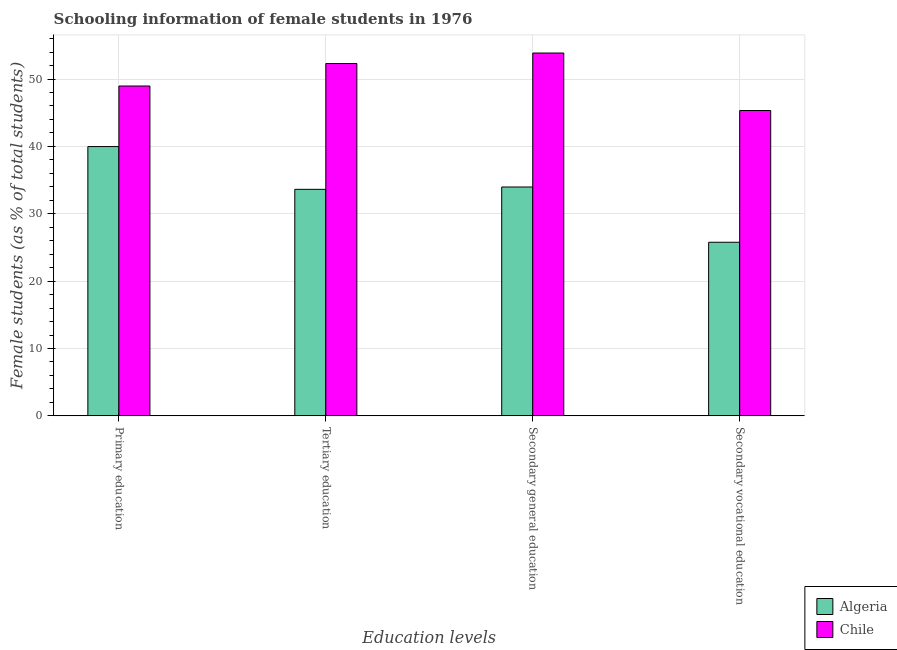Are the number of bars per tick equal to the number of legend labels?
Offer a very short reply. Yes. Are the number of bars on each tick of the X-axis equal?
Ensure brevity in your answer.  Yes. What is the percentage of female students in primary education in Algeria?
Provide a succinct answer. 39.97. Across all countries, what is the maximum percentage of female students in secondary education?
Your answer should be compact. 53.86. Across all countries, what is the minimum percentage of female students in secondary education?
Ensure brevity in your answer.  33.97. In which country was the percentage of female students in secondary education minimum?
Offer a terse response. Algeria. What is the total percentage of female students in secondary education in the graph?
Your answer should be very brief. 87.83. What is the difference between the percentage of female students in primary education in Chile and that in Algeria?
Ensure brevity in your answer.  8.99. What is the difference between the percentage of female students in primary education in Algeria and the percentage of female students in secondary vocational education in Chile?
Offer a terse response. -5.35. What is the average percentage of female students in secondary education per country?
Ensure brevity in your answer.  43.92. What is the difference between the percentage of female students in primary education and percentage of female students in secondary vocational education in Algeria?
Provide a short and direct response. 14.2. What is the ratio of the percentage of female students in secondary education in Algeria to that in Chile?
Provide a short and direct response. 0.63. Is the percentage of female students in secondary vocational education in Algeria less than that in Chile?
Give a very brief answer. Yes. Is the difference between the percentage of female students in secondary education in Algeria and Chile greater than the difference between the percentage of female students in secondary vocational education in Algeria and Chile?
Give a very brief answer. No. What is the difference between the highest and the second highest percentage of female students in secondary vocational education?
Your answer should be compact. 19.55. What is the difference between the highest and the lowest percentage of female students in secondary vocational education?
Offer a very short reply. 19.55. Is it the case that in every country, the sum of the percentage of female students in secondary vocational education and percentage of female students in secondary education is greater than the sum of percentage of female students in tertiary education and percentage of female students in primary education?
Offer a terse response. No. Is it the case that in every country, the sum of the percentage of female students in primary education and percentage of female students in tertiary education is greater than the percentage of female students in secondary education?
Provide a succinct answer. Yes. How many bars are there?
Your response must be concise. 8. Are all the bars in the graph horizontal?
Provide a succinct answer. No. What is the difference between two consecutive major ticks on the Y-axis?
Offer a very short reply. 10. Where does the legend appear in the graph?
Offer a very short reply. Bottom right. How many legend labels are there?
Ensure brevity in your answer.  2. What is the title of the graph?
Provide a short and direct response. Schooling information of female students in 1976. Does "Morocco" appear as one of the legend labels in the graph?
Provide a short and direct response. No. What is the label or title of the X-axis?
Offer a terse response. Education levels. What is the label or title of the Y-axis?
Provide a short and direct response. Female students (as % of total students). What is the Female students (as % of total students) in Algeria in Primary education?
Give a very brief answer. 39.97. What is the Female students (as % of total students) in Chile in Primary education?
Your response must be concise. 48.96. What is the Female students (as % of total students) of Algeria in Tertiary education?
Provide a short and direct response. 33.63. What is the Female students (as % of total students) in Chile in Tertiary education?
Ensure brevity in your answer.  52.3. What is the Female students (as % of total students) of Algeria in Secondary general education?
Offer a very short reply. 33.97. What is the Female students (as % of total students) in Chile in Secondary general education?
Keep it short and to the point. 53.86. What is the Female students (as % of total students) of Algeria in Secondary vocational education?
Your answer should be very brief. 25.77. What is the Female students (as % of total students) in Chile in Secondary vocational education?
Your response must be concise. 45.32. Across all Education levels, what is the maximum Female students (as % of total students) of Algeria?
Provide a short and direct response. 39.97. Across all Education levels, what is the maximum Female students (as % of total students) of Chile?
Your answer should be very brief. 53.86. Across all Education levels, what is the minimum Female students (as % of total students) of Algeria?
Your response must be concise. 25.77. Across all Education levels, what is the minimum Female students (as % of total students) in Chile?
Provide a short and direct response. 45.32. What is the total Female students (as % of total students) of Algeria in the graph?
Make the answer very short. 133.34. What is the total Female students (as % of total students) in Chile in the graph?
Your answer should be compact. 200.44. What is the difference between the Female students (as % of total students) of Algeria in Primary education and that in Tertiary education?
Your answer should be compact. 6.35. What is the difference between the Female students (as % of total students) in Chile in Primary education and that in Tertiary education?
Your answer should be very brief. -3.34. What is the difference between the Female students (as % of total students) in Algeria in Primary education and that in Secondary general education?
Offer a terse response. 6. What is the difference between the Female students (as % of total students) of Chile in Primary education and that in Secondary general education?
Make the answer very short. -4.9. What is the difference between the Female students (as % of total students) in Algeria in Primary education and that in Secondary vocational education?
Provide a short and direct response. 14.2. What is the difference between the Female students (as % of total students) of Chile in Primary education and that in Secondary vocational education?
Give a very brief answer. 3.64. What is the difference between the Female students (as % of total students) of Algeria in Tertiary education and that in Secondary general education?
Provide a short and direct response. -0.35. What is the difference between the Female students (as % of total students) in Chile in Tertiary education and that in Secondary general education?
Offer a very short reply. -1.56. What is the difference between the Female students (as % of total students) in Algeria in Tertiary education and that in Secondary vocational education?
Ensure brevity in your answer.  7.86. What is the difference between the Female students (as % of total students) of Chile in Tertiary education and that in Secondary vocational education?
Offer a very short reply. 6.97. What is the difference between the Female students (as % of total students) of Algeria in Secondary general education and that in Secondary vocational education?
Your answer should be very brief. 8.2. What is the difference between the Female students (as % of total students) of Chile in Secondary general education and that in Secondary vocational education?
Provide a succinct answer. 8.54. What is the difference between the Female students (as % of total students) of Algeria in Primary education and the Female students (as % of total students) of Chile in Tertiary education?
Provide a short and direct response. -12.32. What is the difference between the Female students (as % of total students) in Algeria in Primary education and the Female students (as % of total students) in Chile in Secondary general education?
Provide a short and direct response. -13.89. What is the difference between the Female students (as % of total students) of Algeria in Primary education and the Female students (as % of total students) of Chile in Secondary vocational education?
Your answer should be compact. -5.35. What is the difference between the Female students (as % of total students) in Algeria in Tertiary education and the Female students (as % of total students) in Chile in Secondary general education?
Your answer should be compact. -20.23. What is the difference between the Female students (as % of total students) in Algeria in Tertiary education and the Female students (as % of total students) in Chile in Secondary vocational education?
Your answer should be very brief. -11.7. What is the difference between the Female students (as % of total students) of Algeria in Secondary general education and the Female students (as % of total students) of Chile in Secondary vocational education?
Your response must be concise. -11.35. What is the average Female students (as % of total students) in Algeria per Education levels?
Provide a succinct answer. 33.34. What is the average Female students (as % of total students) in Chile per Education levels?
Keep it short and to the point. 50.11. What is the difference between the Female students (as % of total students) of Algeria and Female students (as % of total students) of Chile in Primary education?
Your response must be concise. -8.99. What is the difference between the Female students (as % of total students) of Algeria and Female students (as % of total students) of Chile in Tertiary education?
Your answer should be compact. -18.67. What is the difference between the Female students (as % of total students) of Algeria and Female students (as % of total students) of Chile in Secondary general education?
Offer a terse response. -19.89. What is the difference between the Female students (as % of total students) of Algeria and Female students (as % of total students) of Chile in Secondary vocational education?
Make the answer very short. -19.55. What is the ratio of the Female students (as % of total students) of Algeria in Primary education to that in Tertiary education?
Keep it short and to the point. 1.19. What is the ratio of the Female students (as % of total students) of Chile in Primary education to that in Tertiary education?
Give a very brief answer. 0.94. What is the ratio of the Female students (as % of total students) of Algeria in Primary education to that in Secondary general education?
Provide a succinct answer. 1.18. What is the ratio of the Female students (as % of total students) of Chile in Primary education to that in Secondary general education?
Provide a short and direct response. 0.91. What is the ratio of the Female students (as % of total students) in Algeria in Primary education to that in Secondary vocational education?
Offer a terse response. 1.55. What is the ratio of the Female students (as % of total students) of Chile in Primary education to that in Secondary vocational education?
Your response must be concise. 1.08. What is the ratio of the Female students (as % of total students) of Algeria in Tertiary education to that in Secondary general education?
Give a very brief answer. 0.99. What is the ratio of the Female students (as % of total students) of Algeria in Tertiary education to that in Secondary vocational education?
Make the answer very short. 1.3. What is the ratio of the Female students (as % of total students) of Chile in Tertiary education to that in Secondary vocational education?
Make the answer very short. 1.15. What is the ratio of the Female students (as % of total students) of Algeria in Secondary general education to that in Secondary vocational education?
Give a very brief answer. 1.32. What is the ratio of the Female students (as % of total students) in Chile in Secondary general education to that in Secondary vocational education?
Your response must be concise. 1.19. What is the difference between the highest and the second highest Female students (as % of total students) in Algeria?
Provide a succinct answer. 6. What is the difference between the highest and the second highest Female students (as % of total students) in Chile?
Provide a succinct answer. 1.56. What is the difference between the highest and the lowest Female students (as % of total students) of Algeria?
Make the answer very short. 14.2. What is the difference between the highest and the lowest Female students (as % of total students) in Chile?
Give a very brief answer. 8.54. 